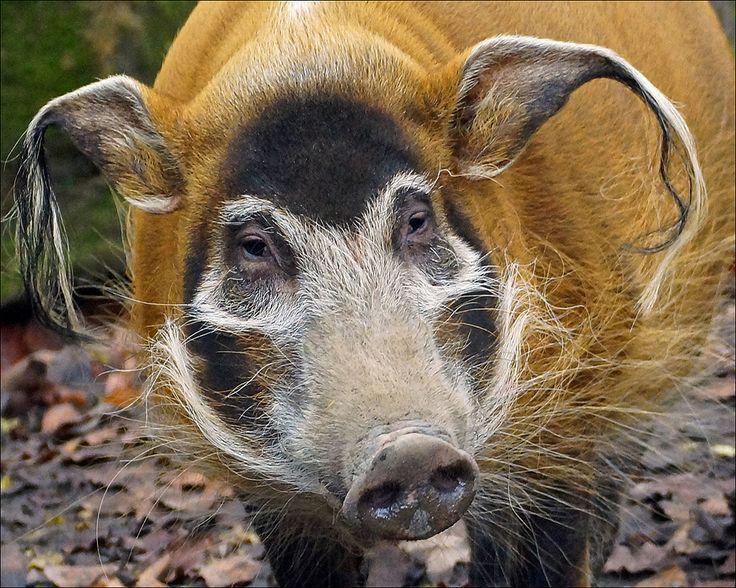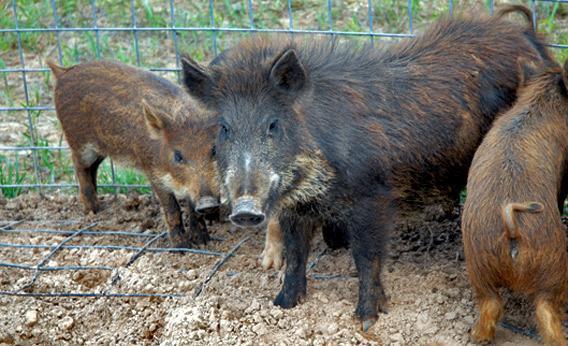The first image is the image on the left, the second image is the image on the right. Examine the images to the left and right. Is the description "All pigs shown in the images face the same direction." accurate? Answer yes or no. No. The first image is the image on the left, the second image is the image on the right. Evaluate the accuracy of this statement regarding the images: "There are two hogs in total.". Is it true? Answer yes or no. No. 